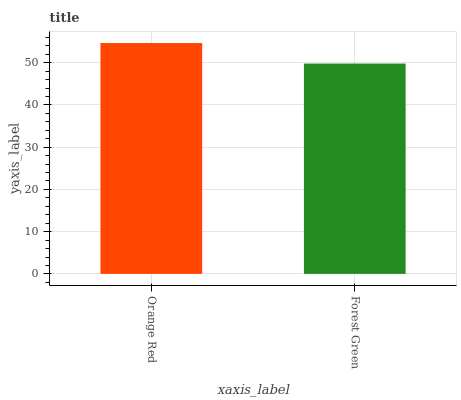Is Forest Green the maximum?
Answer yes or no. No. Is Orange Red greater than Forest Green?
Answer yes or no. Yes. Is Forest Green less than Orange Red?
Answer yes or no. Yes. Is Forest Green greater than Orange Red?
Answer yes or no. No. Is Orange Red less than Forest Green?
Answer yes or no. No. Is Orange Red the high median?
Answer yes or no. Yes. Is Forest Green the low median?
Answer yes or no. Yes. Is Forest Green the high median?
Answer yes or no. No. Is Orange Red the low median?
Answer yes or no. No. 